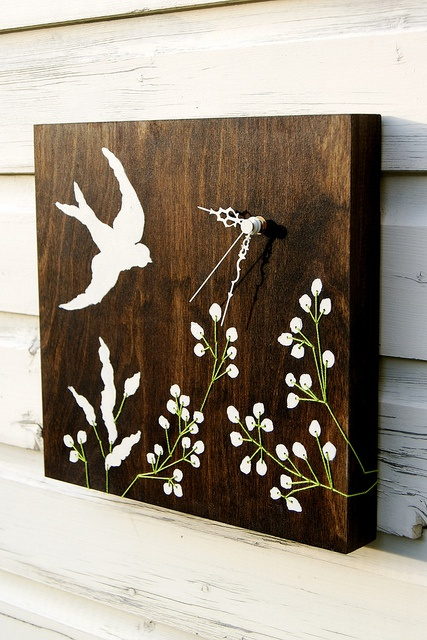Describe the objects in this image and their specific colors. I can see clock in white, black, and maroon tones and bird in white, maroon, gray, and darkgray tones in this image. 